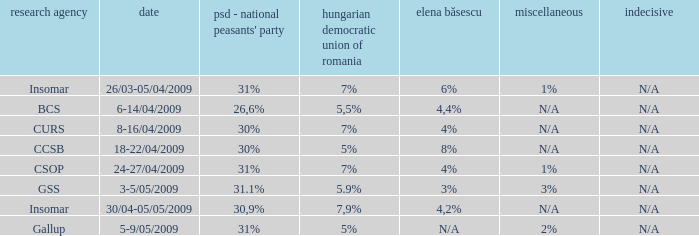What was the polling firm with others of 1%? Insomar, CSOP. 